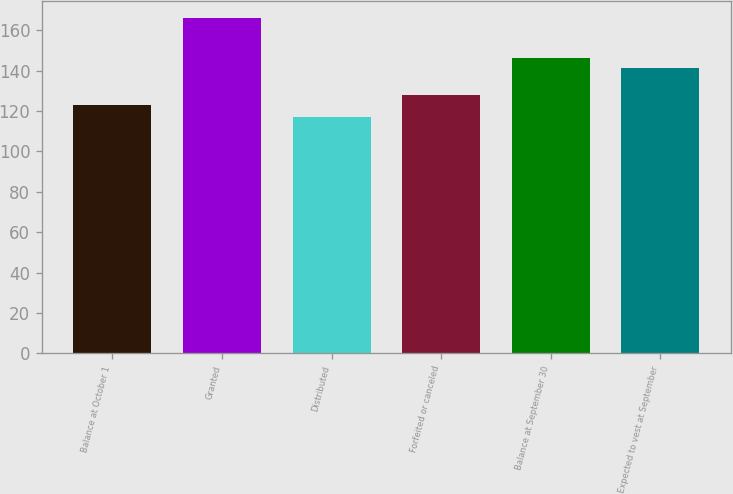Convert chart to OTSL. <chart><loc_0><loc_0><loc_500><loc_500><bar_chart><fcel>Balance at October 1<fcel>Granted<fcel>Distributed<fcel>Forfeited or canceled<fcel>Balance at September 30<fcel>Expected to vest at September<nl><fcel>123.16<fcel>165.96<fcel>117.06<fcel>128.05<fcel>146.25<fcel>141.36<nl></chart> 